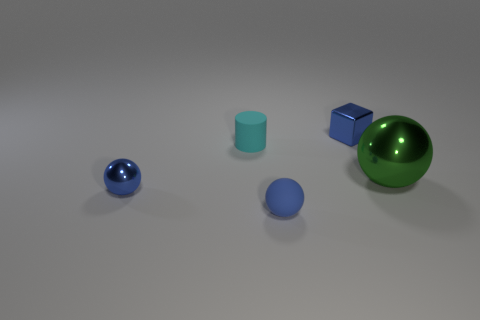There is a small sphere that is on the right side of the cyan matte thing; what is its material?
Keep it short and to the point. Rubber. There is a rubber object that is the same color as the tiny metal cube; what size is it?
Offer a very short reply. Small. Is there a blue matte thing of the same size as the green object?
Provide a succinct answer. No. There is a big metal thing; does it have the same shape as the small shiny thing to the left of the cube?
Your answer should be very brief. Yes. Is the size of the blue object that is behind the big green sphere the same as the metallic object in front of the large green metallic object?
Offer a terse response. Yes. What number of other things are there of the same shape as the tiny cyan matte thing?
Offer a terse response. 0. There is a tiny blue thing in front of the blue metallic thing that is on the left side of the tiny cyan object; what is it made of?
Your answer should be very brief. Rubber. How many shiny things are either big cyan blocks or small things?
Provide a succinct answer. 2. Is there anything else that is the same material as the small cylinder?
Your response must be concise. Yes. There is a metal object that is on the left side of the small metallic cube; is there a tiny cyan thing that is in front of it?
Provide a short and direct response. No. 